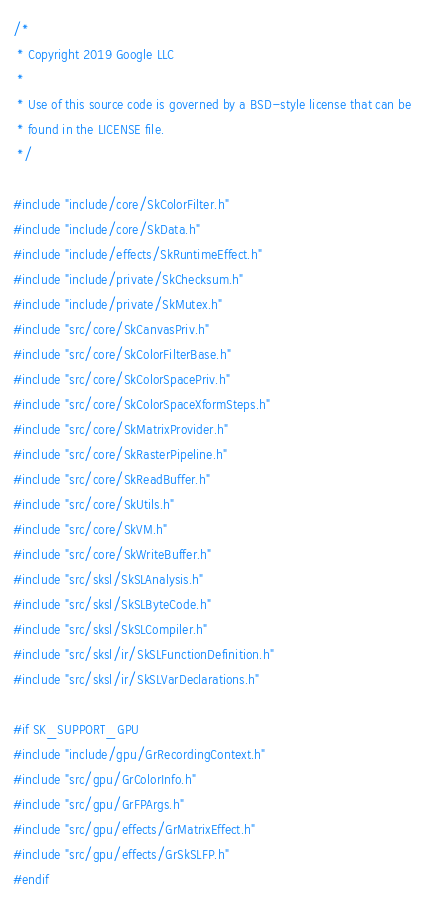Convert code to text. <code><loc_0><loc_0><loc_500><loc_500><_C++_>/*
 * Copyright 2019 Google LLC
 *
 * Use of this source code is governed by a BSD-style license that can be
 * found in the LICENSE file.
 */

#include "include/core/SkColorFilter.h"
#include "include/core/SkData.h"
#include "include/effects/SkRuntimeEffect.h"
#include "include/private/SkChecksum.h"
#include "include/private/SkMutex.h"
#include "src/core/SkCanvasPriv.h"
#include "src/core/SkColorFilterBase.h"
#include "src/core/SkColorSpacePriv.h"
#include "src/core/SkColorSpaceXformSteps.h"
#include "src/core/SkMatrixProvider.h"
#include "src/core/SkRasterPipeline.h"
#include "src/core/SkReadBuffer.h"
#include "src/core/SkUtils.h"
#include "src/core/SkVM.h"
#include "src/core/SkWriteBuffer.h"
#include "src/sksl/SkSLAnalysis.h"
#include "src/sksl/SkSLByteCode.h"
#include "src/sksl/SkSLCompiler.h"
#include "src/sksl/ir/SkSLFunctionDefinition.h"
#include "src/sksl/ir/SkSLVarDeclarations.h"

#if SK_SUPPORT_GPU
#include "include/gpu/GrRecordingContext.h"
#include "src/gpu/GrColorInfo.h"
#include "src/gpu/GrFPArgs.h"
#include "src/gpu/effects/GrMatrixEffect.h"
#include "src/gpu/effects/GrSkSLFP.h"
#endif
</code> 